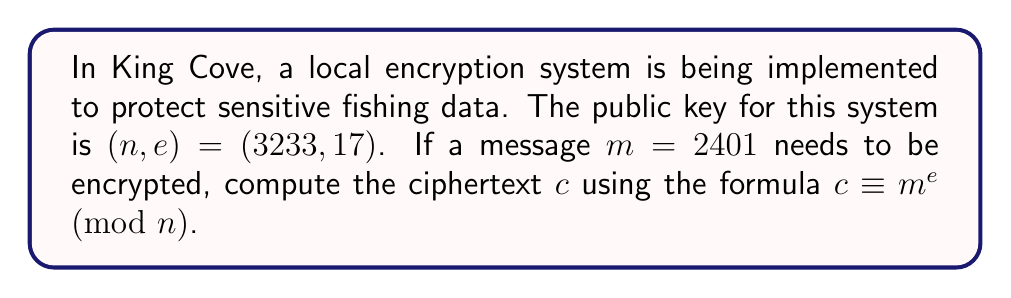What is the answer to this math problem? To compute the modular exponentiation for this public key encryption system, we need to follow these steps:

1) We are given:
   $n = 3233$
   $e = 17$
   $m = 2401$

2) We need to calculate $c \equiv m^e \pmod{n}$

3) This means we need to compute $2401^{17} \pmod{3233}$

4) To do this efficiently, we can use the square-and-multiply algorithm:

   $2401^{17} = 2401^{(10001)_2}$

5) Let's compute the squares:
   $2401^1 \equiv 2401 \pmod{3233}$
   $2401^2 \equiv 1470 \pmod{3233}$
   $2401^4 \equiv 1470^2 \equiv 2116 \pmod{3233}$
   $2401^8 \equiv 2116^2 \equiv 2401 \pmod{3233}$
   $2401^{16} \equiv 2401^2 \equiv 1470 \pmod{3233}$

6) Now, we multiply the results for the 1 bits in 17's binary representation:
   $2401^{17} \equiv 2401^{16} \cdot 2401^1 \pmod{3233}$
   $\equiv 1470 \cdot 2401 \pmod{3233}$
   $\equiv 2799 \pmod{3233}$

Therefore, the ciphertext $c$ is 2799.
Answer: $c = 2799$ 